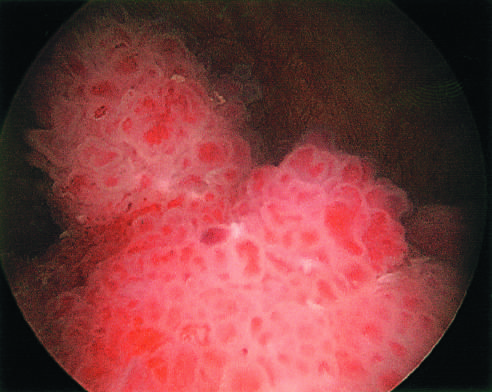what resemble coral, within the bladder?
Answer the question using a single word or phrase. Papillary urothelial tumor 